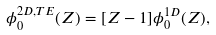Convert formula to latex. <formula><loc_0><loc_0><loc_500><loc_500>\phi ^ { 2 D , T E } _ { 0 } ( Z ) = [ Z - 1 ] \phi ^ { 1 D } _ { 0 } ( Z ) ,</formula> 